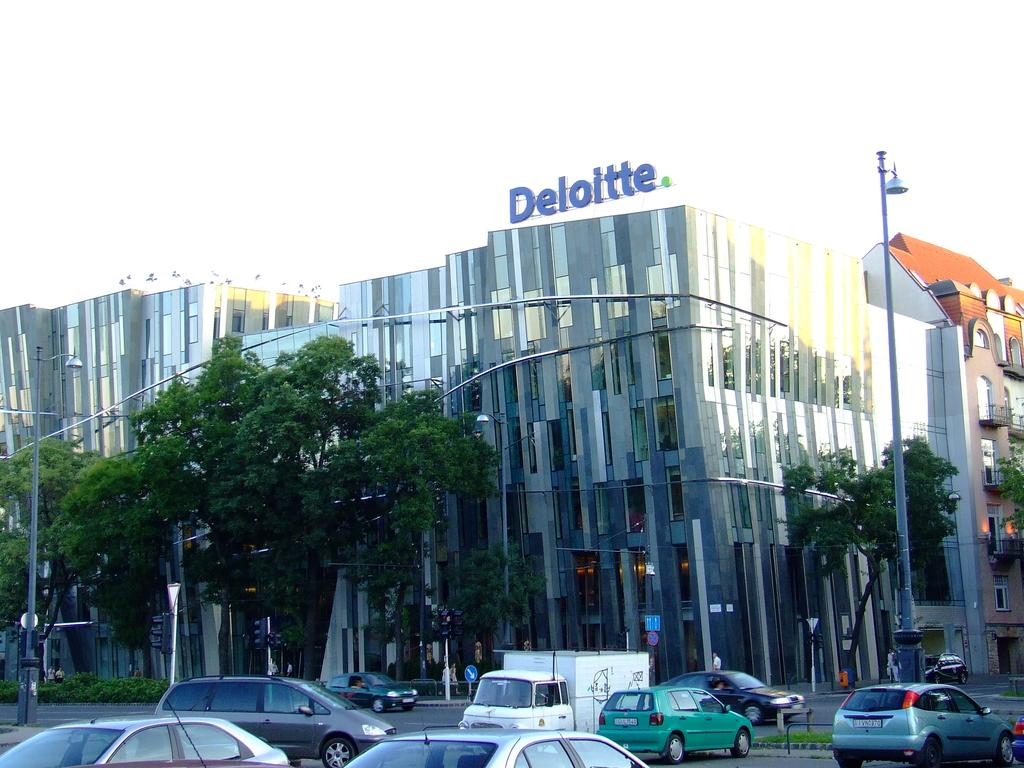What can be seen on the road in the image? There are vehicles on the road in the image. What is present in the background of the image? In the background, there are lights attached to poles, trees, buildings with glass windows, and the sky. Can you describe the buildings in the background? The buildings in the background have glass windows. What type of plants can be seen growing out of the vehicles' mouths in the image? There are no plants or mouths present on the vehicles in the image. 